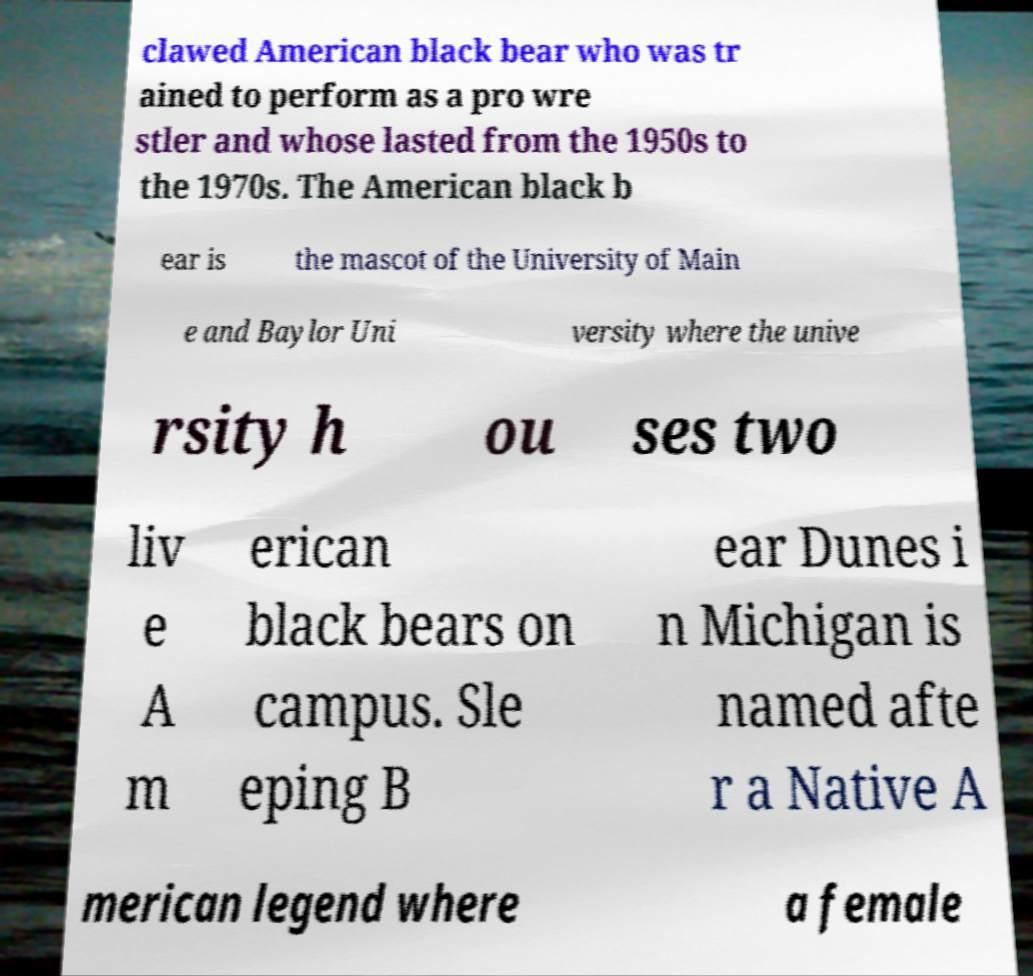Can you accurately transcribe the text from the provided image for me? clawed American black bear who was tr ained to perform as a pro wre stler and whose lasted from the 1950s to the 1970s. The American black b ear is the mascot of the University of Main e and Baylor Uni versity where the unive rsity h ou ses two liv e A m erican black bears on campus. Sle eping B ear Dunes i n Michigan is named afte r a Native A merican legend where a female 